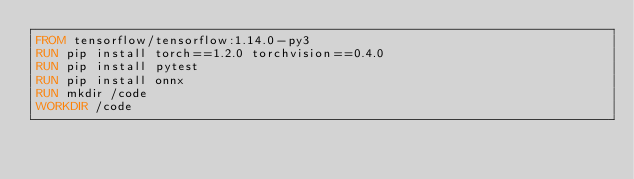Convert code to text. <code><loc_0><loc_0><loc_500><loc_500><_Dockerfile_>FROM tensorflow/tensorflow:1.14.0-py3
RUN pip install torch==1.2.0 torchvision==0.4.0
RUN pip install pytest
RUN pip install onnx
RUN mkdir /code
WORKDIR /code
</code> 